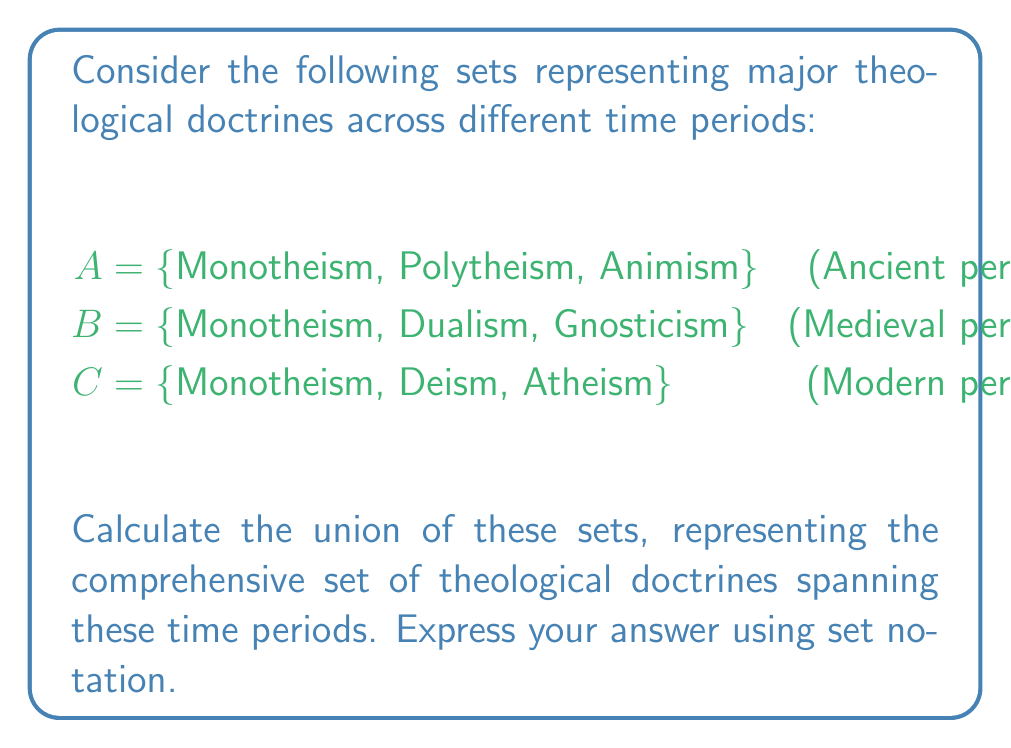Provide a solution to this math problem. To solve this problem, we need to understand the concept of union in set theory and apply it to the given sets of theological doctrines.

Step 1: Recall the definition of union.
The union of sets A, B, and C, denoted as $A \cup B \cup C$, is the set of all elements that belong to at least one of the sets A, B, or C.

Step 2: List all unique elements from sets A, B, and C.
- From set A: Monotheism, Polytheism, Animism
- From set B: Monotheism (already listed), Dualism, Gnosticism
- From set C: Monotheism (already listed), Deism, Atheism

Step 3: Combine all unique elements into a single set.
The union will contain all these elements without repetition.

Step 4: Express the result using set notation.
We use curly braces {} to enclose the elements of the set, separating each element with a comma.

$$A \cup B \cup C = \{Monotheism, Polytheism, Animism, Dualism, Gnosticism, Deism, Atheism\}$$

This union represents the comprehensive set of theological doctrines spanning the ancient, medieval, and modern periods as defined in the question.
Answer: $\{Monotheism, Polytheism, Animism, Dualism, Gnosticism, Deism, Atheism\}$ 